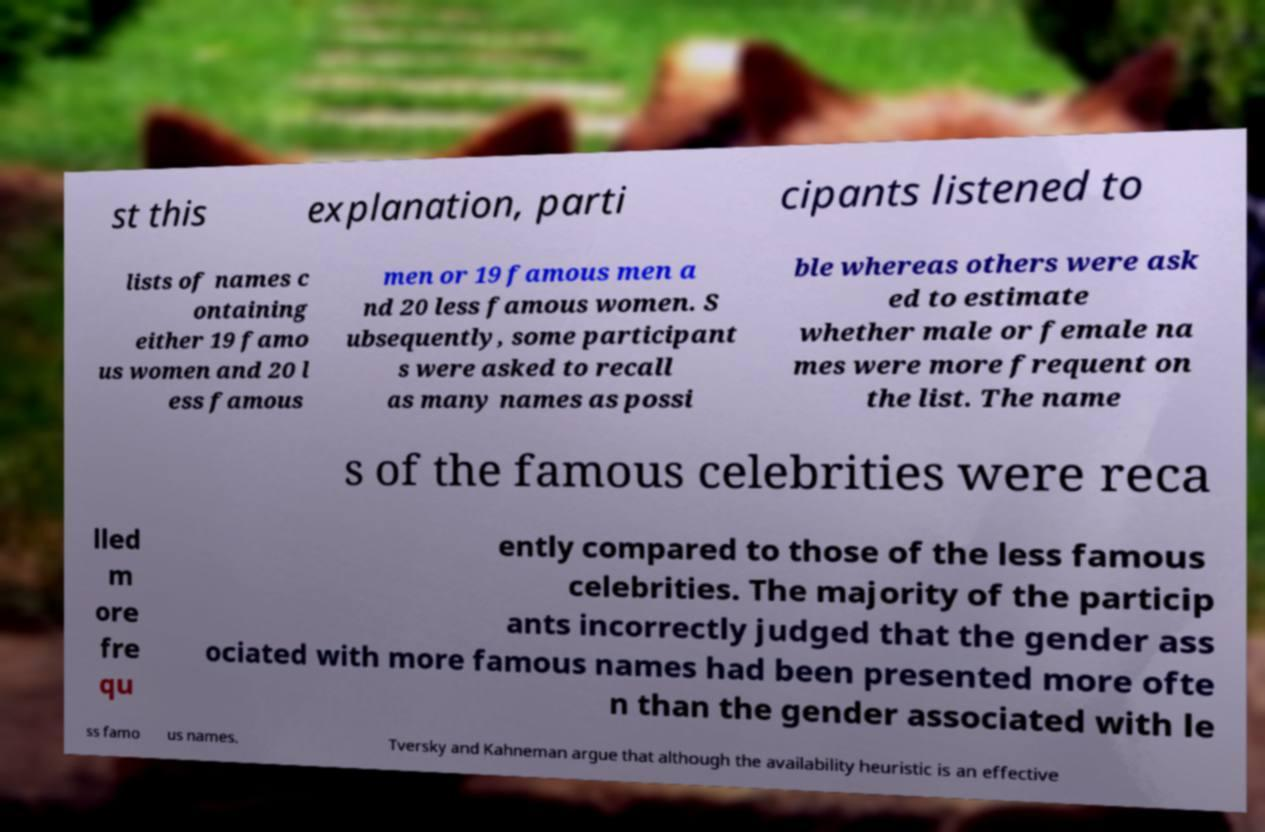I need the written content from this picture converted into text. Can you do that? st this explanation, parti cipants listened to lists of names c ontaining either 19 famo us women and 20 l ess famous men or 19 famous men a nd 20 less famous women. S ubsequently, some participant s were asked to recall as many names as possi ble whereas others were ask ed to estimate whether male or female na mes were more frequent on the list. The name s of the famous celebrities were reca lled m ore fre qu ently compared to those of the less famous celebrities. The majority of the particip ants incorrectly judged that the gender ass ociated with more famous names had been presented more ofte n than the gender associated with le ss famo us names. Tversky and Kahneman argue that although the availability heuristic is an effective 